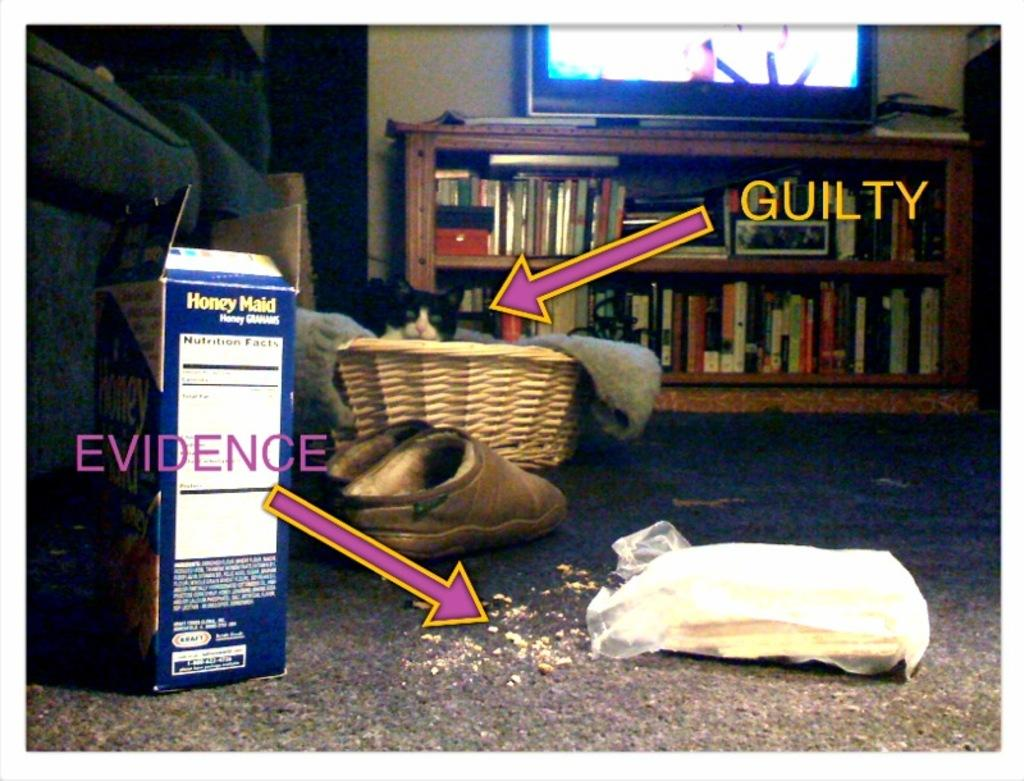<image>
Write a terse but informative summary of the picture. Box and some crumbs on the floor with an arrow that says EVIDENCE. 